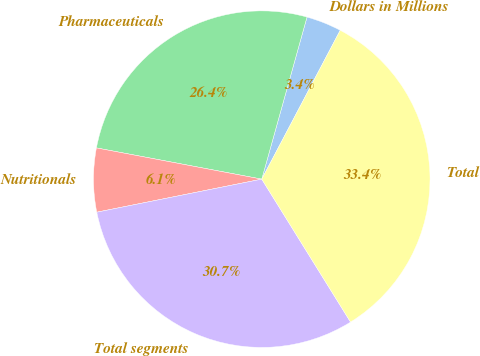Convert chart to OTSL. <chart><loc_0><loc_0><loc_500><loc_500><pie_chart><fcel>Dollars in Millions<fcel>Pharmaceuticals<fcel>Nutritionals<fcel>Total segments<fcel>Total<nl><fcel>3.39%<fcel>26.36%<fcel>6.12%<fcel>30.7%<fcel>33.43%<nl></chart> 